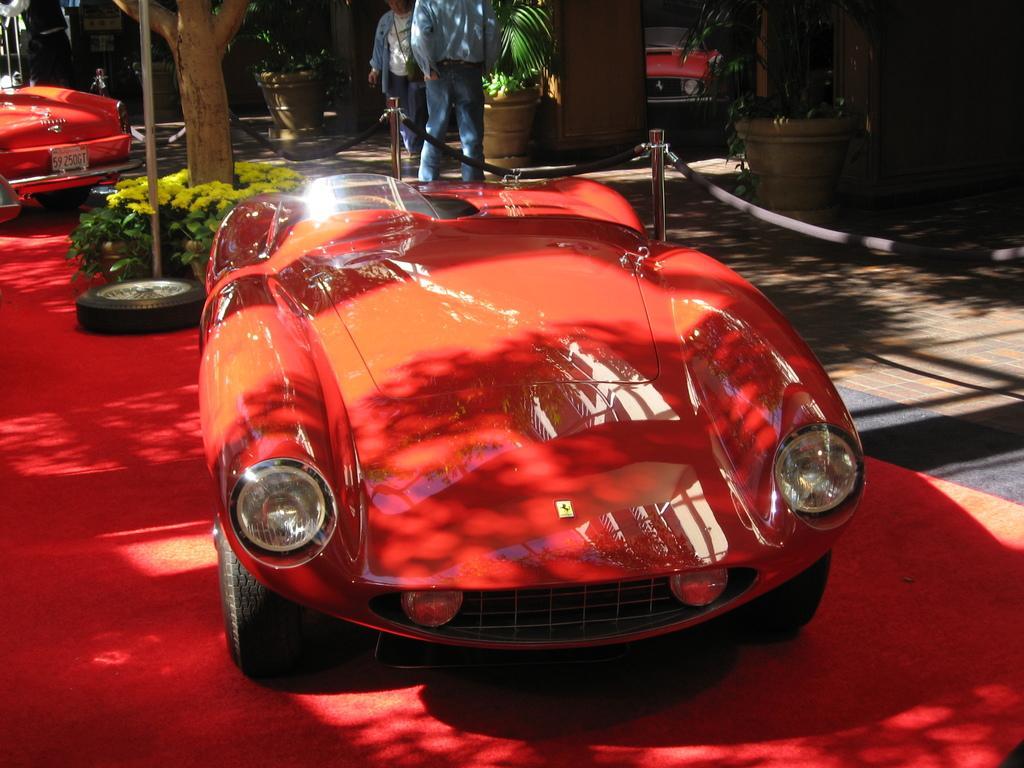Describe this image in one or two sentences. In this image, we can see a car which is colored red. There is a barricade stand in the middle of the image. There are persons and plants at the top of the image. There is a stem and pole in the top left of the image. There is wheel beside the car. 